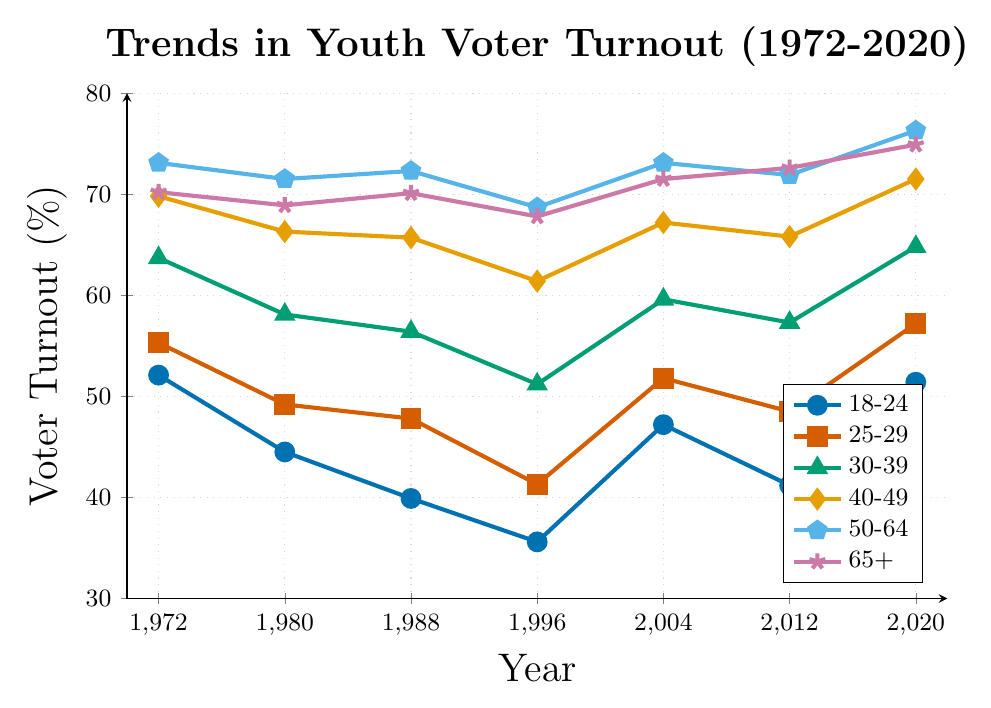What is the trend for the 18-24 age group over the entire time period? The 18-24 age group shows a general decline from 1972 (52.1%) to 1996 (35.6%), after which there is a fluctuating increase, reaching 51.4% in 2020.
Answer: General decline followed by increasing fluctuation Which age group had the highest voter turnout in 2020? In 2020, the 50-64 age group had the highest voter turnout at 76.3%.
Answer: 50-64 How does the voter turnout for the 65+ age group in 1988 compare to the 25-29 age group in 2004? The 65+ age group had a voter turnout of 70.1% in 1988, while the 25-29 age group had a turnout of 51.8% in 2004.
Answer: 65+ in 1988 is higher Which age group experienced the largest decrease in voter turnout from 1972 to 1980? The 18-24 age group experienced the largest decrease, dropping from 52.1% in 1972 to 44.5% in 1980, totaling a decrease of 7.6 percentage points.
Answer: 18-24 What is the average voter turnout for the 40-49 age group across all years presented? Summing up the percentages for the 40-49 age group (69.8, 66.3, 65.7, 61.4, 67.2, 65.8, 71.5) and then dividing by the number of data points (7), the average is (69.8 + 66.3 + 65.7 + 61.4 + 67.2 + 65.8 + 71.5)/7 ≈ 66.8%.
Answer: 66.8% In which year did the 30-39 age group have its lowest voter turnout, and what was the percentage? The lowest voter turnout for the 30-39 age group was in 1996, with a percentage of 51.2%.
Answer: 1996, 51.2% Which age group showed the smallest change in voter turnout between 1972 and 2020? The 65+ age group showed the smallest change, starting at 70.2% in 1972 and ending at 74.9% in 2020, a change of 4.7 percentage points.
Answer: 65+ Compare the voter turnout trends of the 30-39 and 40-49 age groups. Both age groups show a general declining trend from 1972 to 1996. After 1996, both groups demonstrate a rising trend, but the 40-49 age group consistently has higher voter turnout percentages compared to the 30-39 age group.
Answer: Both decline, then rise; 40-49 higher Which age group had the steepest increase in voter turnout from 2012 to 2020? The 18-24 age group had the steepest increase in voter turnout from 41.2% in 2012 to 51.4% in 2020, an increase of 10.2 percentage points.
Answer: 18-24 How does the turnout of the 50-64 age group in 2004 compare to all other groups in the same year? In 2004, the 50-64 age group had a turnout of 73.1%, which was the highest compared to all other groups: 18-24 (47.2%), 25-29 (51.8%), 30-39 (59.6%), 40-49 (67.2%), and 65+ (71.5%).
Answer: Highest 